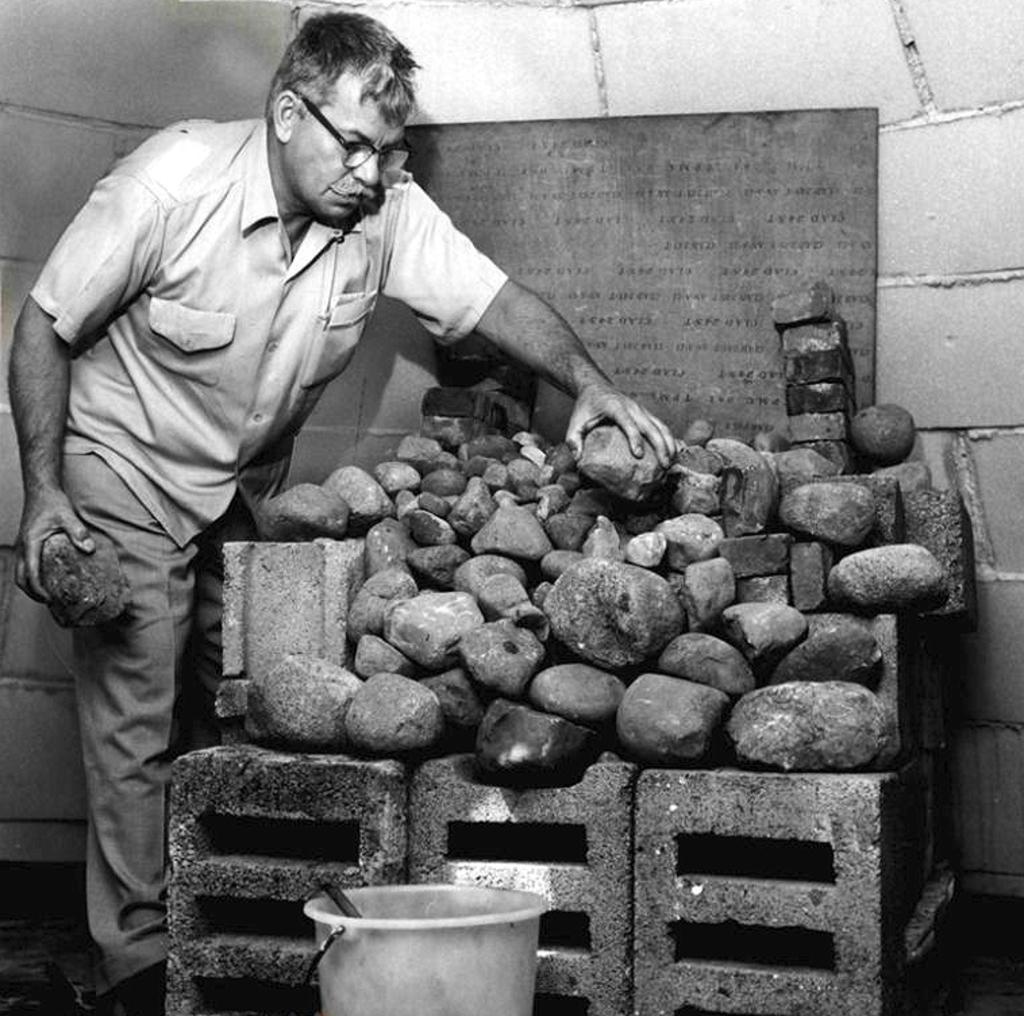How would you summarize this image in a sentence or two? In this black and white image, we can see a person wearing clothes and holding rocks with his hands. There is a bucket at the bottom of the image. There are some rocks in front of the wall. 